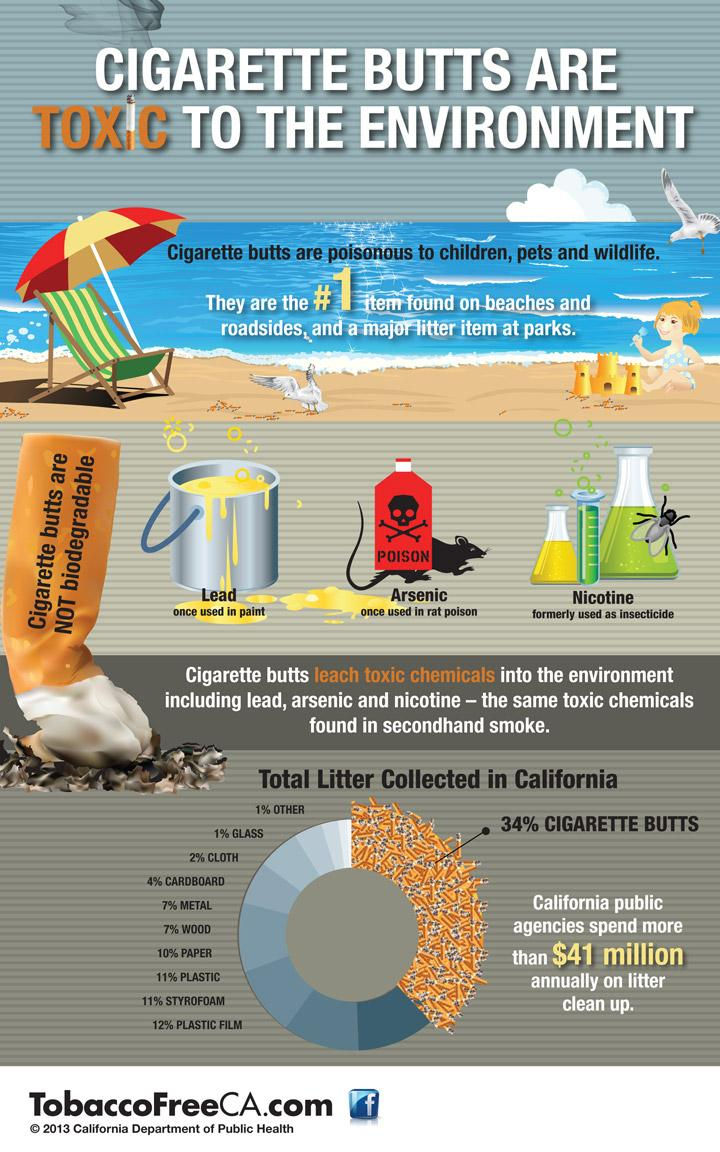Identify some key points in this picture. Cigarette butts are not biodegradable, they are non-biodegradable. In California, 33% of litter collected consists of paper, plastic film, and plastic. 